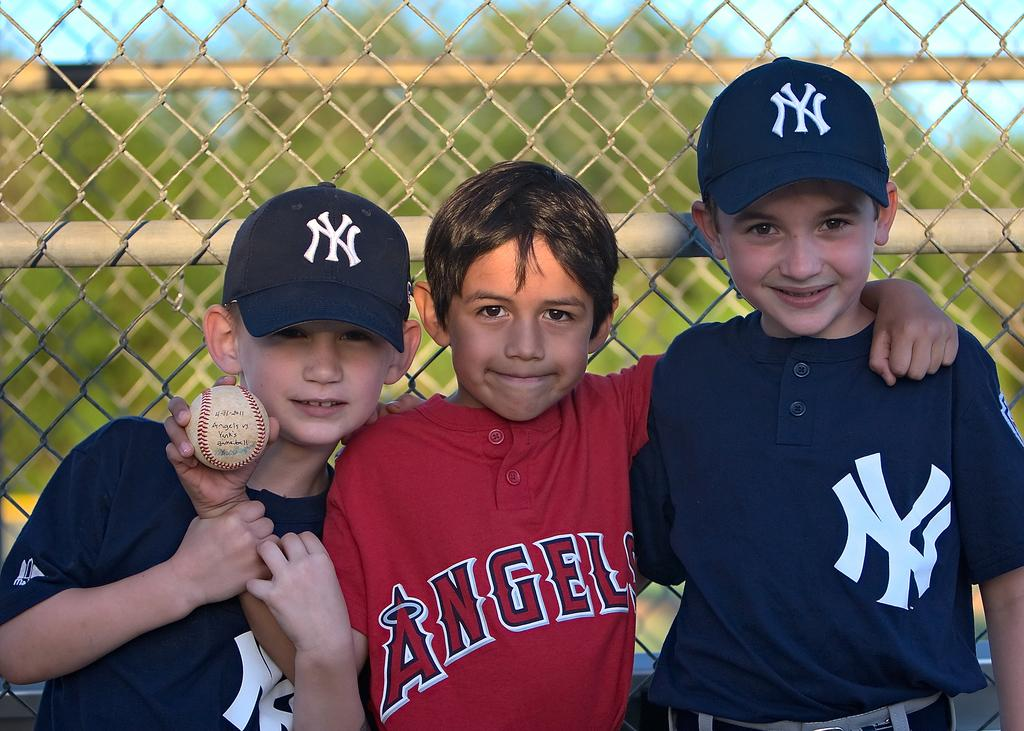<image>
Offer a succinct explanation of the picture presented. small boys hug, center one in angels jersey and ones on his sides wearing ny jerseys and caps 